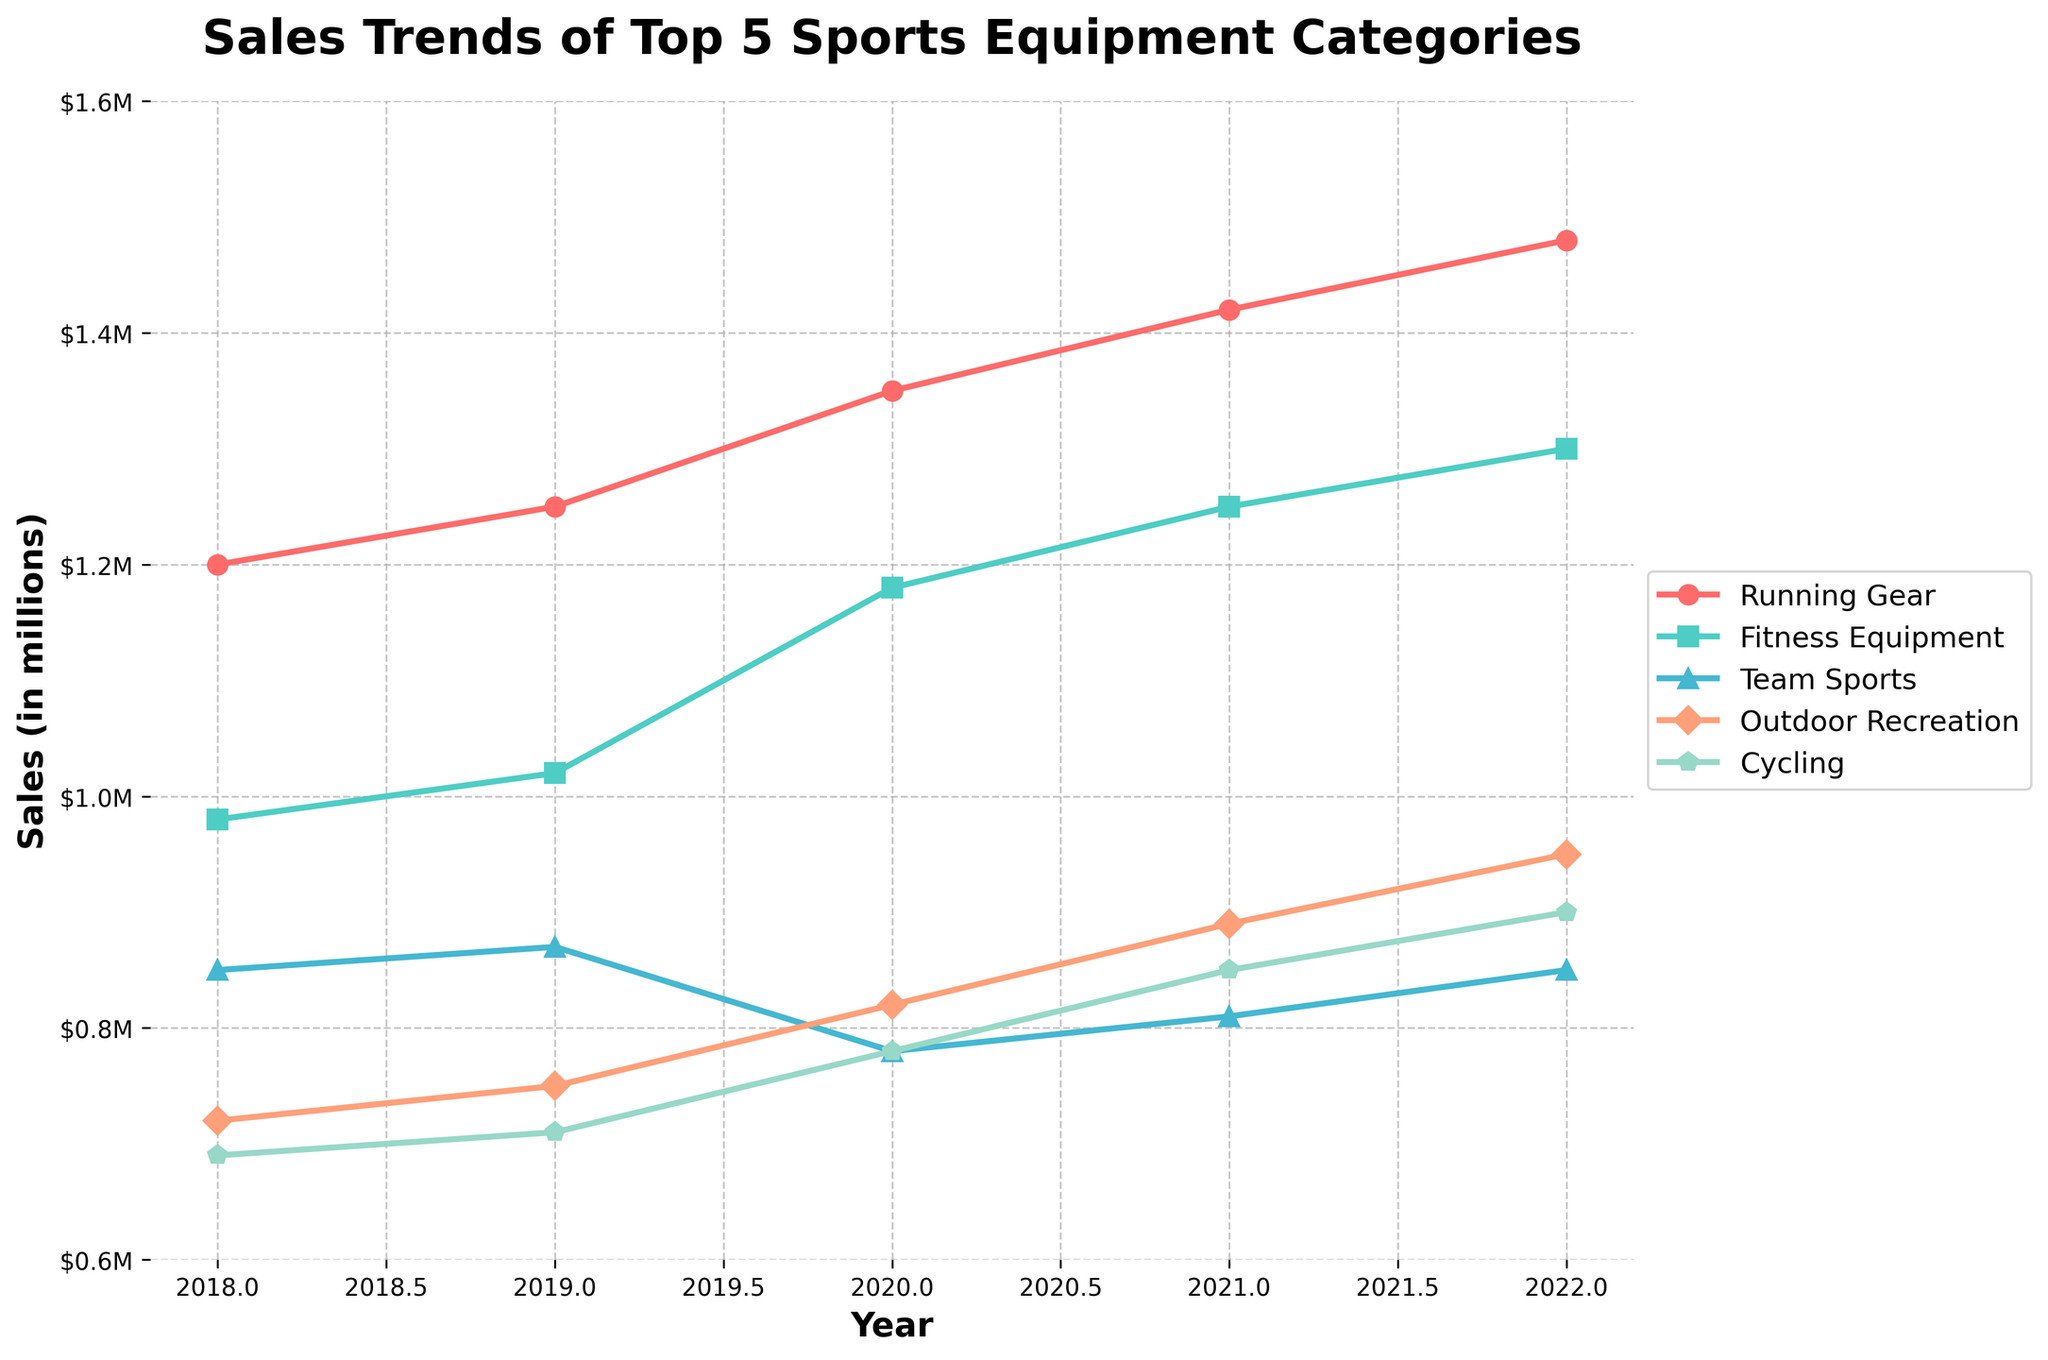What was the sales trend for Running Gear over the past 5 years? By observing the plot for Running Gear, the sales start at $1,200,000 in 2018 and increase each year, reaching $1,480,000 in 2022.
Answer: Increasing trend Which category had the highest sales in 2022? By examining the heights of the endpoints for each line, the Running Gear category has the highest value in 2022, reaching $1,480,000.
Answer: Running Gear Which two categories had the smallest difference in sales in 2020? Comparing the values of each category in 2020, Team Sports and Outdoor Recreation had values of $780,000 and $820,000 respectively. The difference between these values is $40,000, which is the smallest difference.
Answer: Team Sports and Outdoor Recreation How many categories had a sales increase every year from 2018 to 2022? By visually inspecting the lines, we can see that Running Gear, Fitness Equipment, Outdoor Recreation, and Cycling have consistent upward trends each year.
Answer: 4 What was the combined sales of Team Sports and Cycling in 2020? The sales for Team Sports in 2020 were $780,000 and for Cycling were $780,000. Adding these together gives a total of $780,000 + $780,000 = $1,560,000.
Answer: $1,560,000 Which category had the highest increase in sales between 2018 and 2022? Calculate the difference in sales for each category from 2018 to 2022. Running Gear increased by $1,480,000 - $1,200,000 = $280,000, which is the highest increase among all categories.
Answer: Running Gear Which year saw the highest total sales across all categories? Summing the sales of all categories for each year and comparing: 2018 has a total of $4,440,000, 2019 has $4,720,000, 2020 has $4,810,000, 2021 has $4,980,000, and 2022 has $5,030,000. The maximum total sales were in 2022.
Answer: 2022 Are there any categories where the sales decrease at any point? Observing the trends visually, only Team Sports' sales decreased from 2019 to 2020.
Answer: Yes, Team Sports Which categories' sales surpassed $1,000,000 in any given year? Visual inspection shows that Running Gear, Fitness Equipment, and Outdoor Recreation all surpassed $1,000,000 in sales in various years.
Answer: Running Gear, Fitness Equipment, and Outdoor Recreation What's the average sales for Fitness Equipment over the 5 years? Summing the sales of Fitness Equipment from 2018 to 2022 gives $980,000 + $1,020,000 + $1,180,000 + $1,250,000 + $1,300,000 = $5,730,000. Dividing by 5 gives an average of $5,730,000 / 5 = $1,146,000.
Answer: $1,146,000 